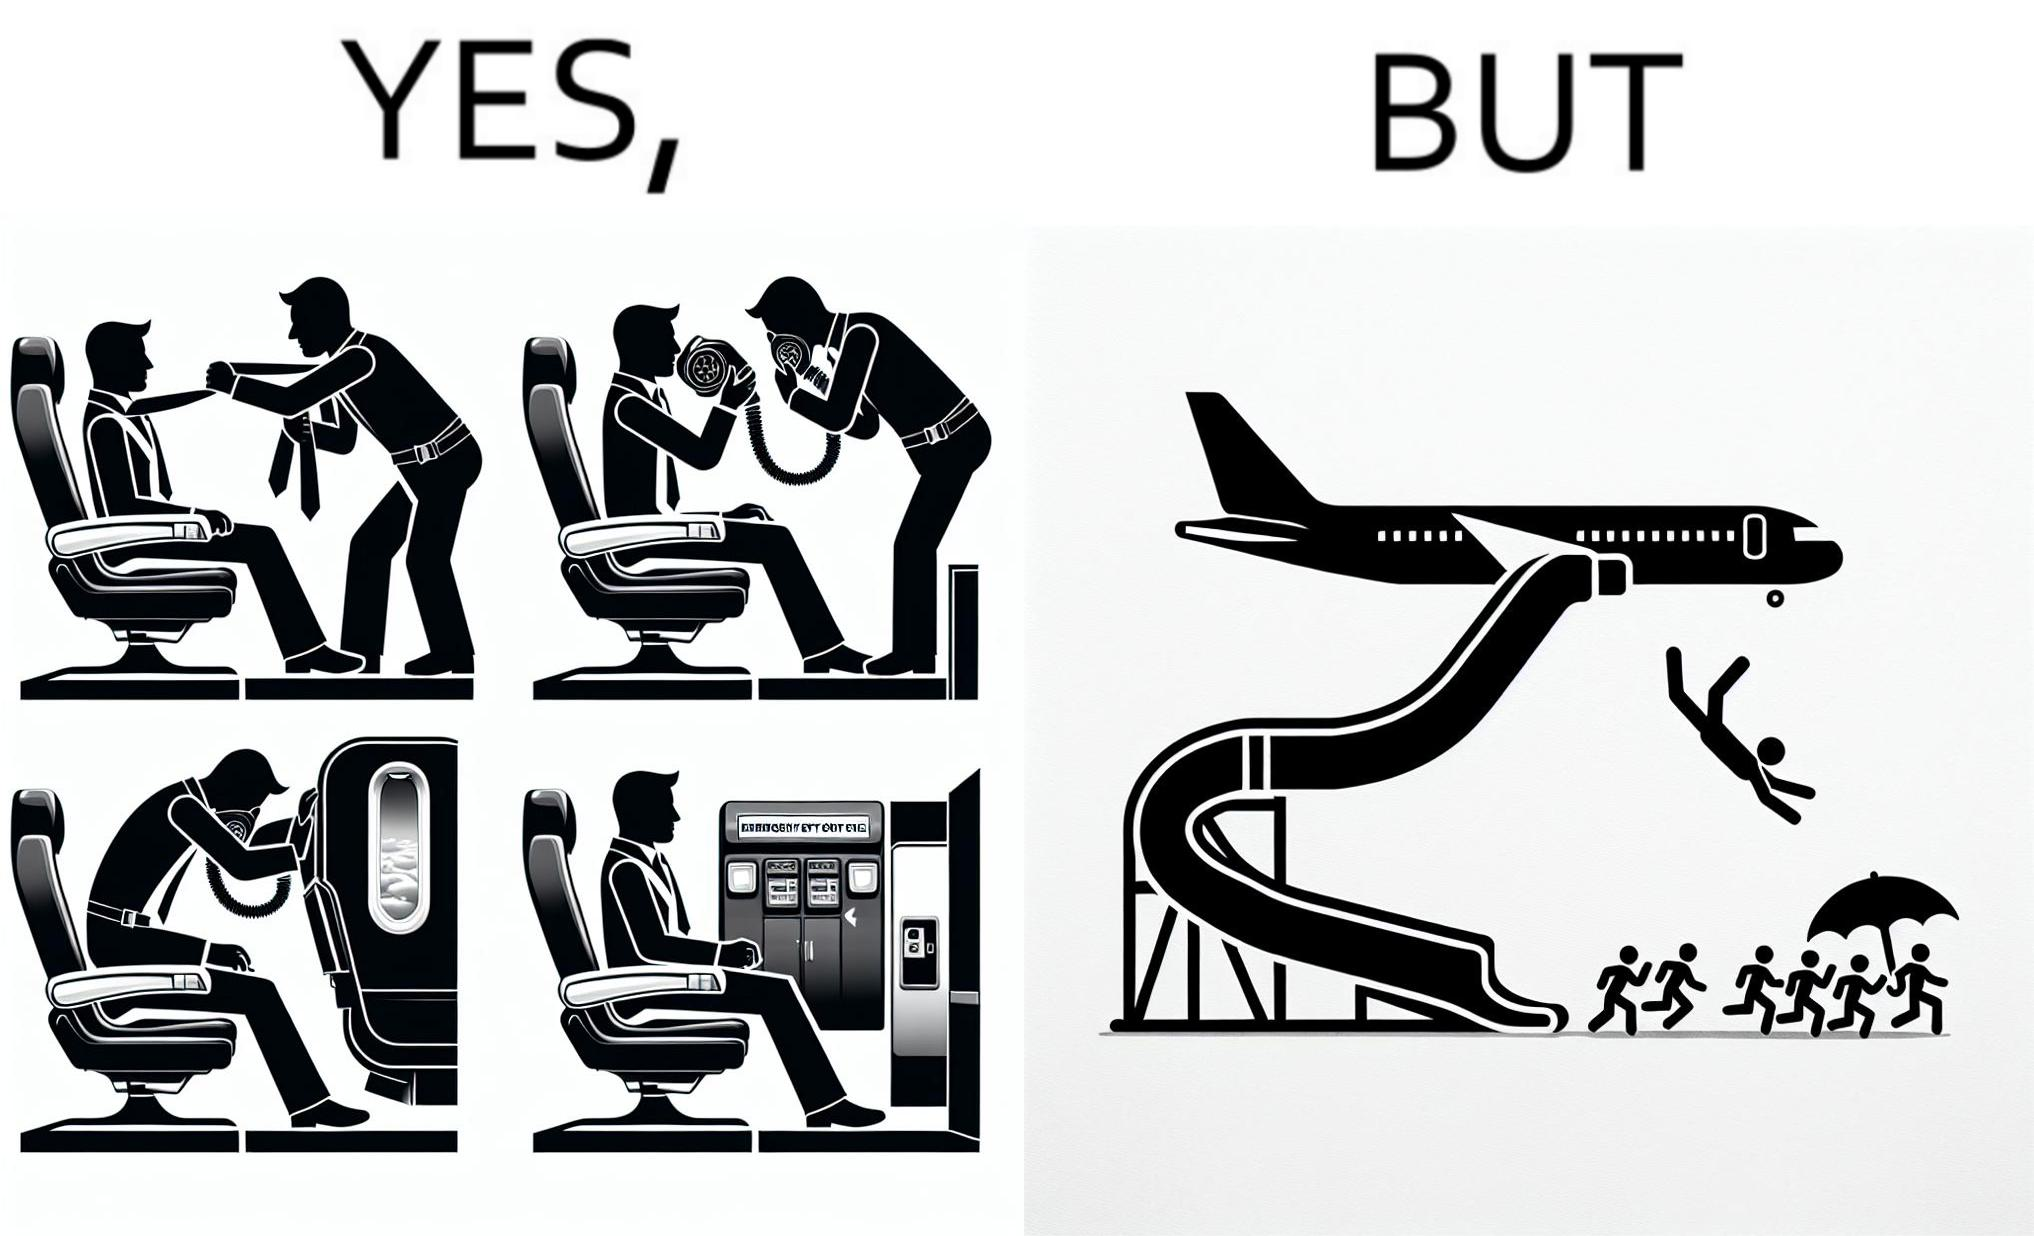Is this image satirical or non-satirical? Yes, this image is satirical. 